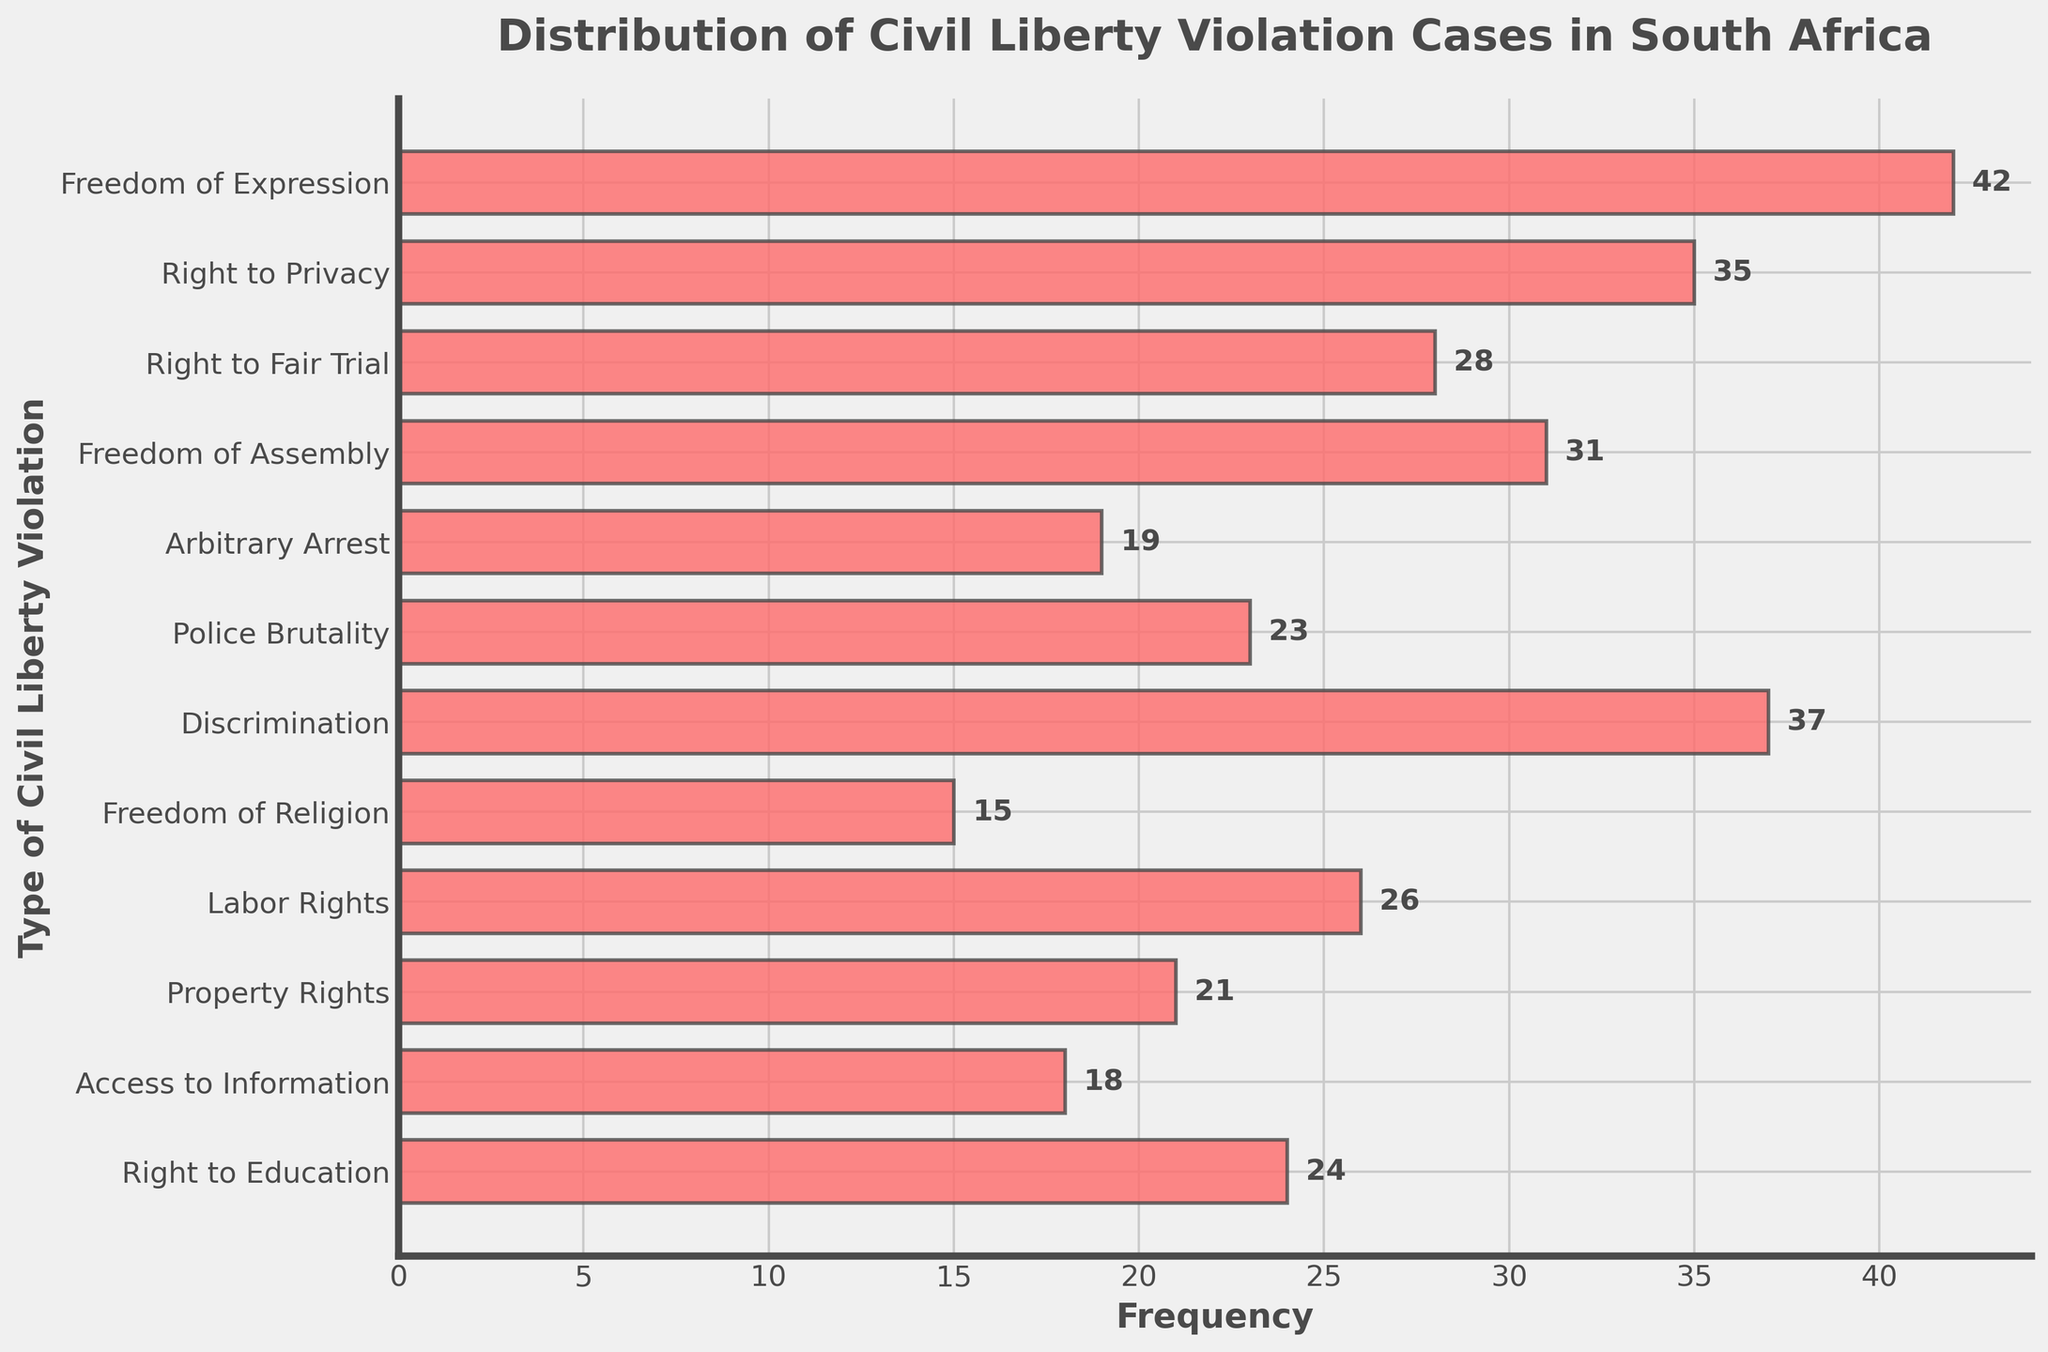How many types of civil liberty violations are depicted in the plot? Count the number of data points (bars) shown in the plot.
Answer: 12 Which type of civil liberty violation has the highest frequency? Identify the bar that extends the farthest along the x-axis.
Answer: Freedom of Expression What is the frequency of Police Brutality cases? Locate the bar corresponding to "Police Brutality" and read its length on the x-axis.
Answer: 23 How many more cases of Discrimination are there compared to Freedom of Religion? Subtract the frequency of "Freedom of Religion" from the frequency of "Discrimination". (37 - 15 = 22)
Answer: 22 What is the combined frequency of Freedom of Assembly and Right to Education violations? Add the frequencies of "Freedom of Assembly" and "Right to Education". (31 + 24 = 55)
Answer: 55 Which type of violation has the lowest frequency and what is it? Identify the bar with the shortest length on the x-axis.
Answer: Freedom of Religion, 15 How many types of violations have a frequency of 30 or more? Count the number of bars that extend to a value of 30 or beyond on the x-axis.
Answer: 4 Which violations have a frequency between 20 and 30? Identify and list bars where their x-axis values fall within the range of 20 to 30.
Answer: Right to Fair Trial, Police Brutality, Labor Rights, Property Rights, Right to Education Is the frequency of Arbitrary Arrest cases greater than Access to Information cases? If so, by how much? Subtract the frequency of "Access to Information" from "Arbitrary Arrest". (19 - 18 = 1)
Answer: Yes, by 1 What is the average frequency of the violations listed? Sum all the frequencies and divide by the number of types. [(42 + 35 + 28 + 31 + 19 + 23 + 37 + 15 + 26 + 21 + 18 + 24) / 12 = 466 / 12 ≈ 38.83]
Answer: ~38.83 